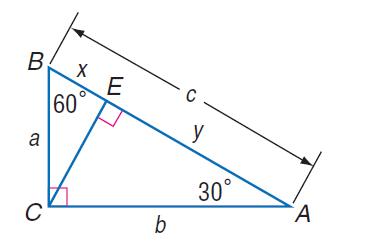Answer the mathemtical geometry problem and directly provide the correct option letter.
Question: If x = 7 \sqrt { 3 }, find b.
Choices: A: 7 B: 7 \sqrt { 3 } C: 14 \sqrt { 3 } D: 42 D 